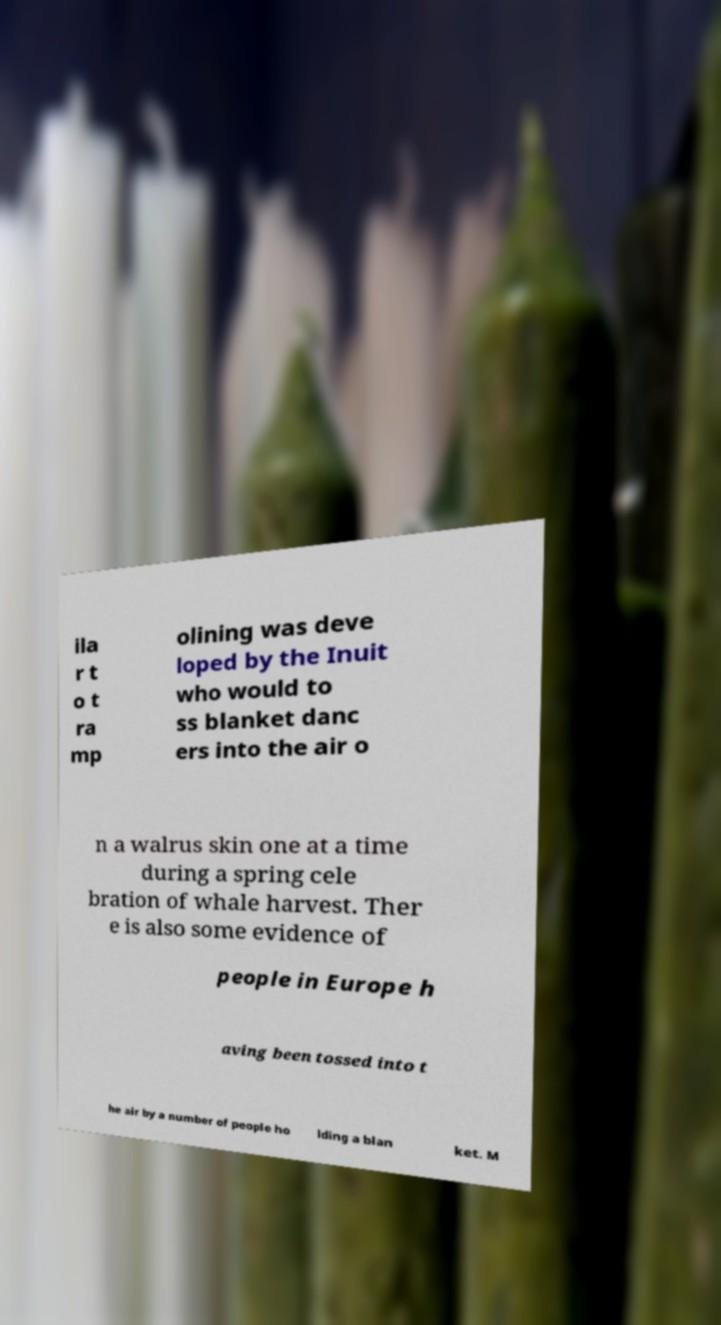Could you assist in decoding the text presented in this image and type it out clearly? ila r t o t ra mp olining was deve loped by the Inuit who would to ss blanket danc ers into the air o n a walrus skin one at a time during a spring cele bration of whale harvest. Ther e is also some evidence of people in Europe h aving been tossed into t he air by a number of people ho lding a blan ket. M 